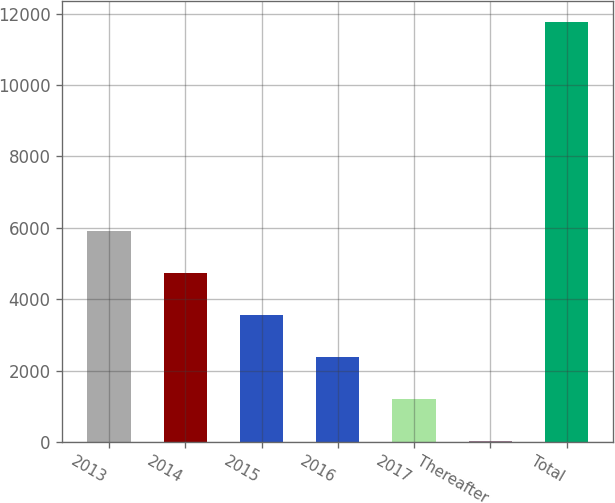Convert chart. <chart><loc_0><loc_0><loc_500><loc_500><bar_chart><fcel>2013<fcel>2014<fcel>2015<fcel>2016<fcel>2017<fcel>Thereafter<fcel>Total<nl><fcel>5901.5<fcel>4727<fcel>3552.5<fcel>2378<fcel>1203.5<fcel>29<fcel>11774<nl></chart> 